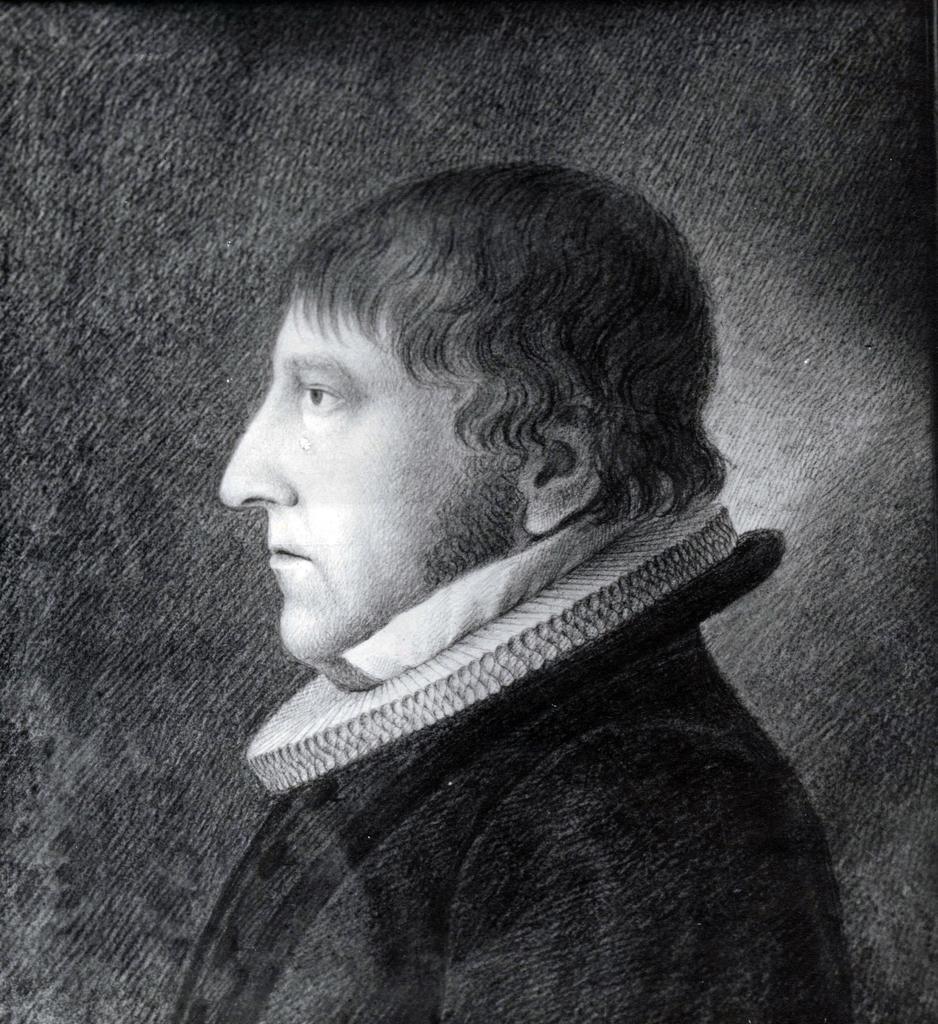Describe this image in one or two sentences. In this image I can see the person and the image is in black and white. 